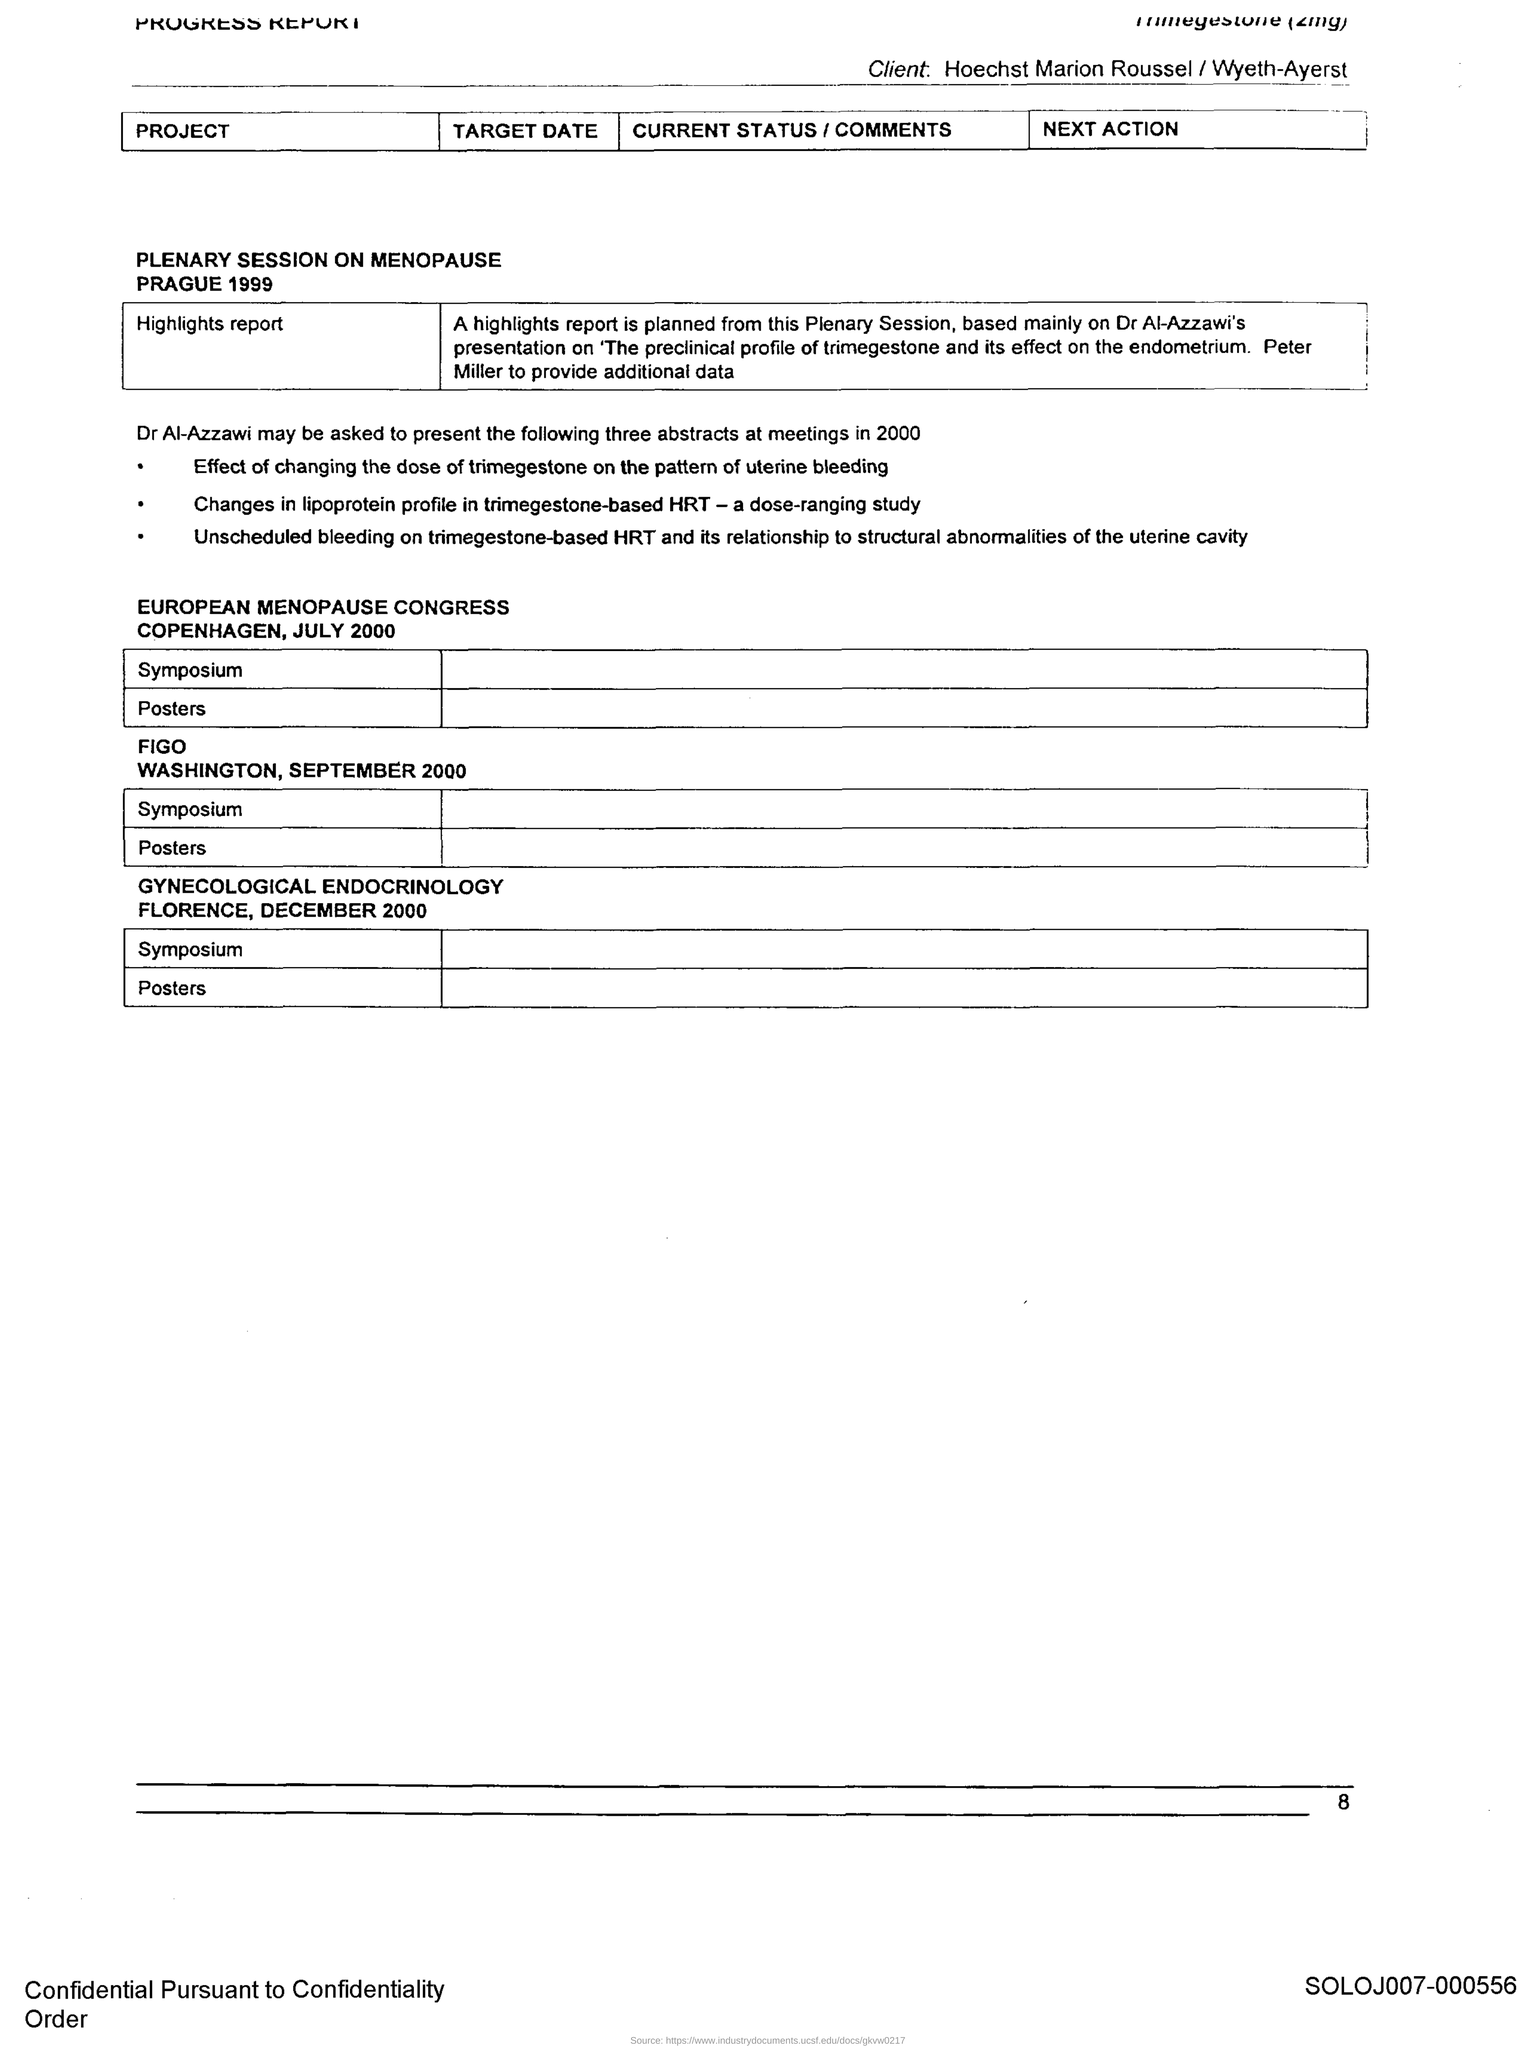What is the Page Number?
Your answer should be compact. 8. Plenary session on the menopause held on which year?
Your response must be concise. 1999. European Menopause Congress held in which place?
Give a very brief answer. Copenhagen. Gynecological Endocrinology session held in which place?
Your answer should be compact. Florence. 